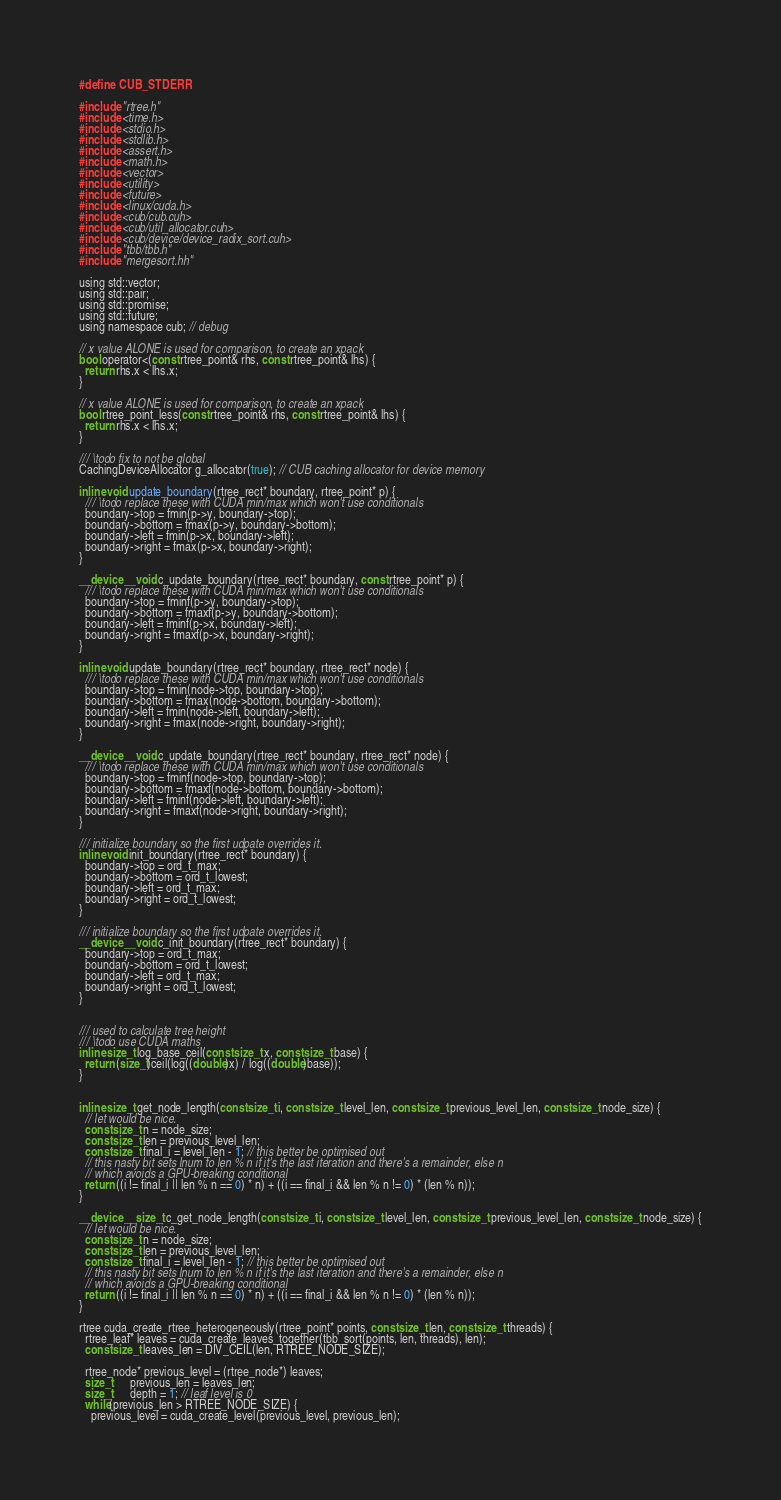Convert code to text. <code><loc_0><loc_0><loc_500><loc_500><_Cuda_>#define CUB_STDERR

#include "rtree.h"
#include <time.h>
#include <stdio.h>
#include <stdlib.h>    
#include <assert.h>
#include <math.h>
#include <vector>
#include <utility>
#include <future>
#include <linux/cuda.h>
#include <cub/cub.cuh>
#include <cub/util_allocator.cuh>
#include <cub/device/device_radix_sort.cuh>
#include "tbb/tbb.h"
#include "mergesort.hh"

using std::vector;
using std::pair;
using std::promise;
using std::future;
using namespace cub; // debug

// x value ALONE is used for comparison, to create an xpack
bool operator<(const rtree_point& rhs, const rtree_point& lhs) {
  return rhs.x < lhs.x;
}

// x value ALONE is used for comparison, to create an xpack
bool rtree_point_less(const rtree_point& rhs, const rtree_point& lhs) {
  return rhs.x < lhs.x;
}

/// \todo fix to not be global
CachingDeviceAllocator g_allocator(true); // CUB caching allocator for device memory

inline void update_boundary(rtree_rect* boundary, rtree_point* p) {
  /// \todo replace these with CUDA min/max which won't use conditionals
  boundary->top = fmin(p->y, boundary->top);
  boundary->bottom = fmax(p->y, boundary->bottom);
  boundary->left = fmin(p->x, boundary->left);
  boundary->right = fmax(p->x, boundary->right);
}

__device__ void c_update_boundary(rtree_rect* boundary, const rtree_point* p) {
  /// \todo replace these with CUDA min/max which won't use conditionals
  boundary->top = fminf(p->y, boundary->top);
  boundary->bottom = fmaxf(p->y, boundary->bottom);
  boundary->left = fminf(p->x, boundary->left);
  boundary->right = fmaxf(p->x, boundary->right);
}

inline void update_boundary(rtree_rect* boundary, rtree_rect* node) {
  /// \todo replace these with CUDA min/max which won't use conditionals
  boundary->top = fmin(node->top, boundary->top);
  boundary->bottom = fmax(node->bottom, boundary->bottom);
  boundary->left = fmin(node->left, boundary->left);
  boundary->right = fmax(node->right, boundary->right);
}

__device__ void c_update_boundary(rtree_rect* boundary, rtree_rect* node) {
  /// \todo replace these with CUDA min/max which won't use conditionals
  boundary->top = fminf(node->top, boundary->top);
  boundary->bottom = fmaxf(node->bottom, boundary->bottom);
  boundary->left = fminf(node->left, boundary->left);
  boundary->right = fmaxf(node->right, boundary->right);
}

/// initialize boundary so the first udpate overrides it.
inline void init_boundary(rtree_rect* boundary) {
  boundary->top = ord_t_max;
  boundary->bottom = ord_t_lowest;
  boundary->left = ord_t_max;
  boundary->right = ord_t_lowest;
}

/// initialize boundary so the first udpate overrides it.
__device__ void c_init_boundary(rtree_rect* boundary) {
  boundary->top = ord_t_max;
  boundary->bottom = ord_t_lowest;
  boundary->left = ord_t_max;
  boundary->right = ord_t_lowest;
}


/// used to calculate tree height
/// \todo use CUDA maths
inline size_t log_base_ceil(const size_t x, const size_t base) {
  return (size_t)ceil(log((double)x) / log((double)base));
}


inline size_t get_node_length(const size_t i, const size_t level_len, const size_t previous_level_len, const size_t node_size) {
  // let would be nice.
  const size_t n = node_size;
  const size_t len = previous_level_len;
  const size_t final_i = level_len - 1; // this better be optimised out
  // this nasty bit sets lnum to len % n if it's the last iteration and there's a remainder, else n
  // which avoids a GPU-breaking conditional
  return ((i != final_i || len % n == 0) * n) + ((i == final_i && len % n != 0) * (len % n));
}

__device__ size_t c_get_node_length(const size_t i, const size_t level_len, const size_t previous_level_len, const size_t node_size) {
  // let would be nice.
  const size_t n = node_size;
  const size_t len = previous_level_len;
  const size_t final_i = level_len - 1; // this better be optimised out
  // this nasty bit sets lnum to len % n if it's the last iteration and there's a remainder, else n
  // which avoids a GPU-breaking conditional
  return ((i != final_i || len % n == 0) * n) + ((i == final_i && len % n != 0) * (len % n));
}

rtree cuda_create_rtree_heterogeneously(rtree_point* points, const size_t len, const size_t threads) {
  rtree_leaf* leaves = cuda_create_leaves_together(tbb_sort(points, len, threads), len);
  const size_t leaves_len = DIV_CEIL(len, RTREE_NODE_SIZE);

  rtree_node* previous_level = (rtree_node*) leaves;
  size_t      previous_len = leaves_len;
  size_t      depth = 1; // leaf level is 0
  while(previous_len > RTREE_NODE_SIZE) {
    previous_level = cuda_create_level(previous_level, previous_len);</code> 